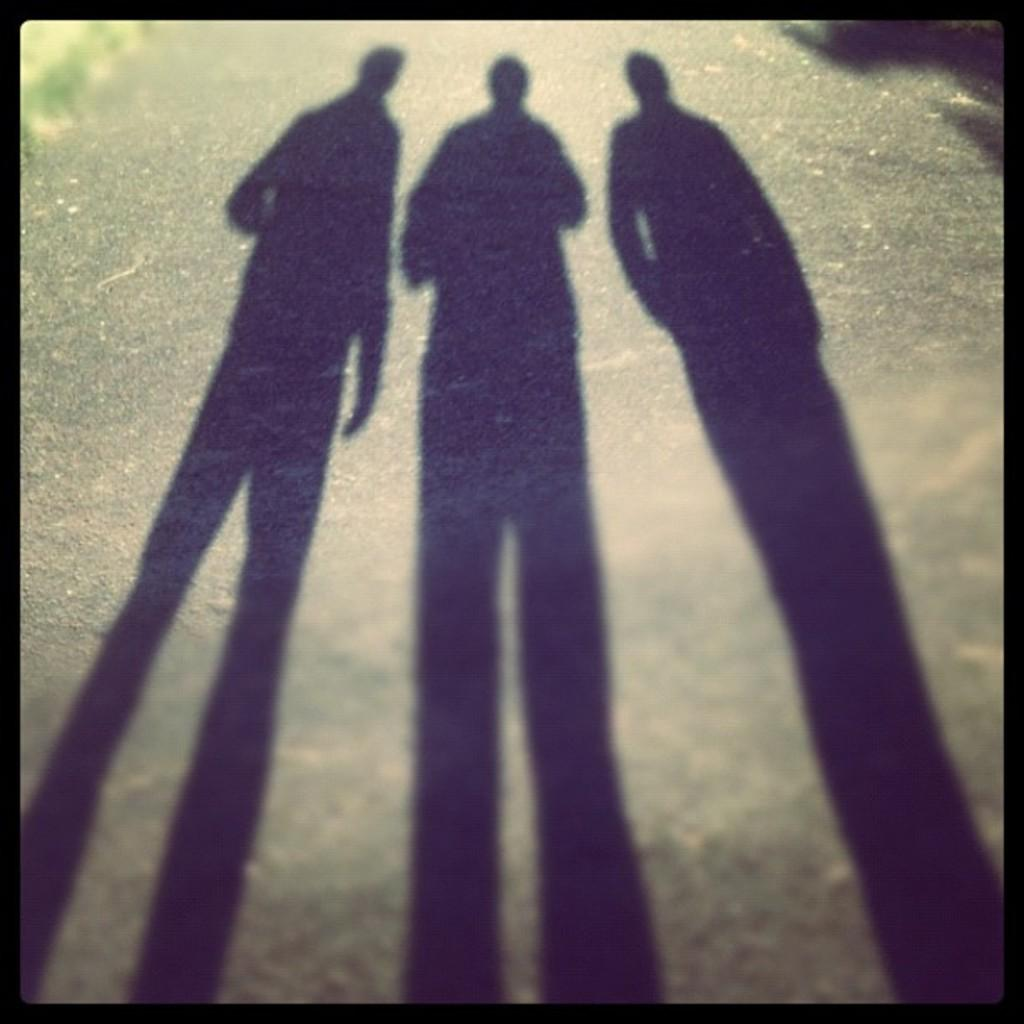What can be seen on the ground in the image? There are shadows of three people on the ground in the image. What type of account can be seen being settled in the image? There is no account being settled in the image; it only features shadows of three people on the ground. What type of match is being played in the image? There is no match being played in the image; it only features shadows of three people on the ground. 